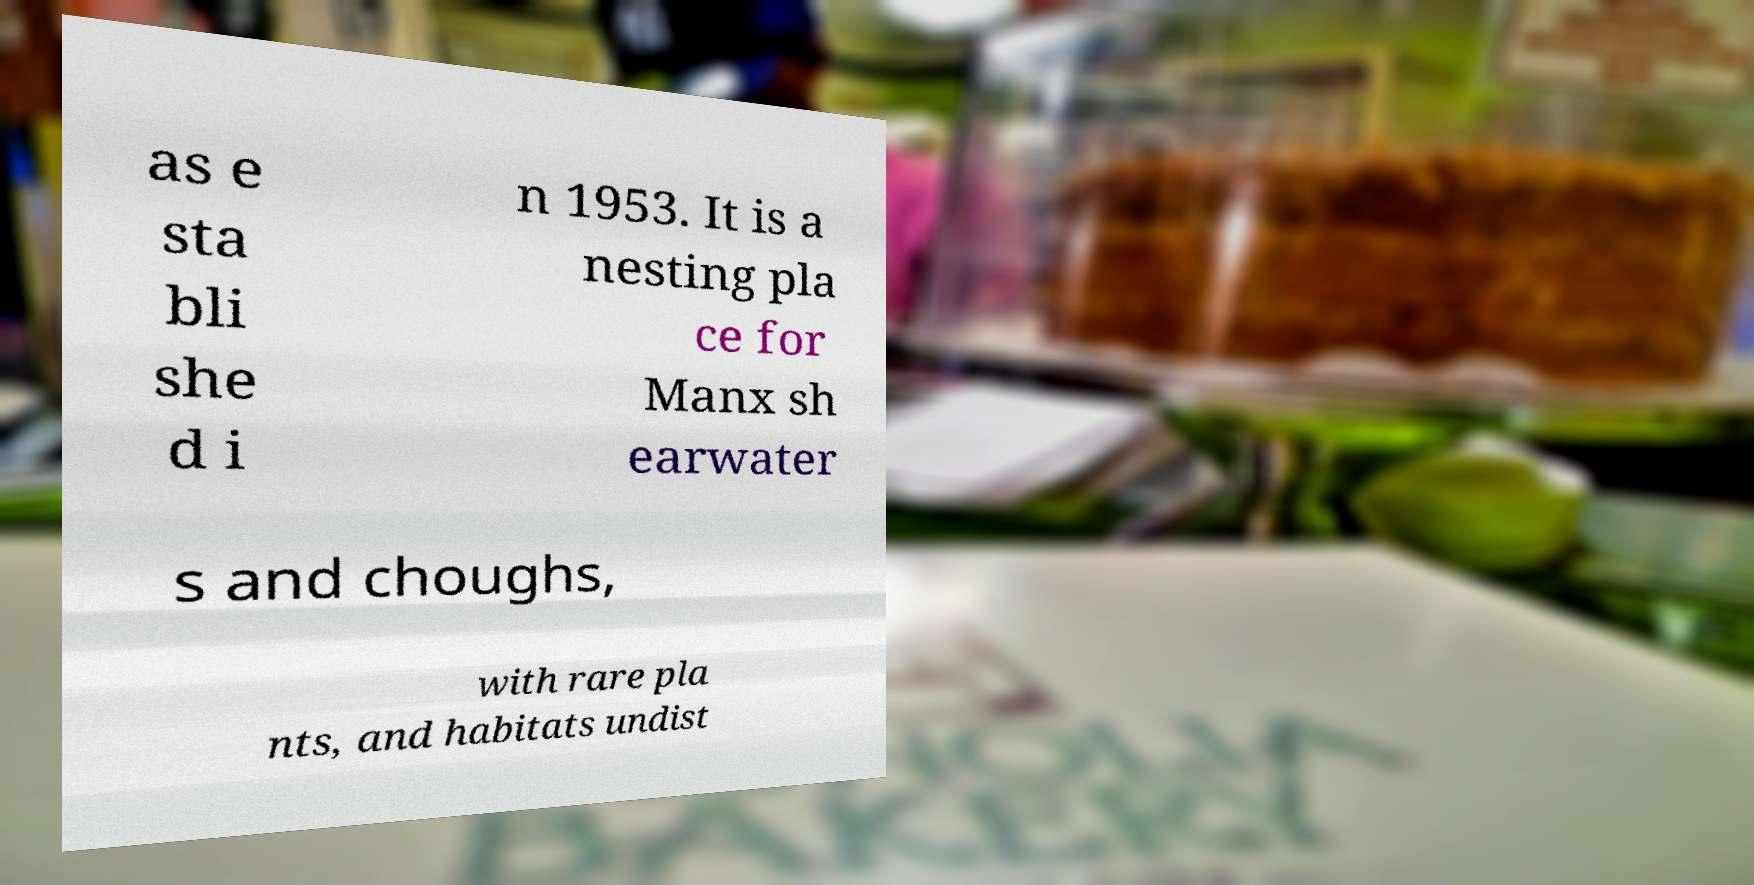Could you extract and type out the text from this image? as e sta bli she d i n 1953. It is a nesting pla ce for Manx sh earwater s and choughs, with rare pla nts, and habitats undist 